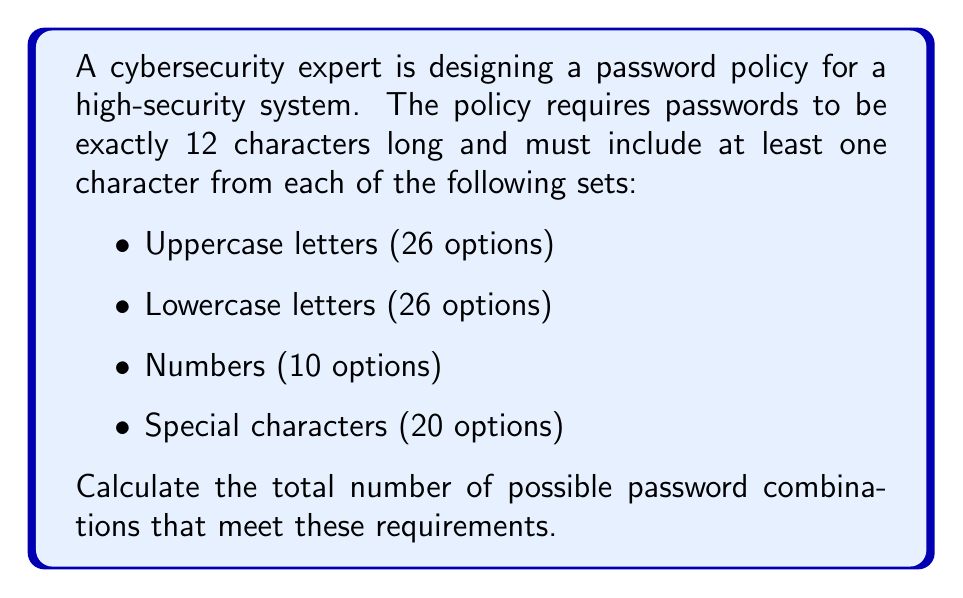Can you solve this math problem? To solve this problem, we'll use the multiplication principle and the inclusion-exclusion principle.

Step 1: Calculate the total number of 12-character strings without restrictions.
$$T = 82^{12}$$ (82 is the sum of all character options: 26 + 26 + 10 + 20)

Step 2: Calculate the number of strings missing at least one character set.
Let A, B, C, and D represent the sets of strings missing uppercase, lowercase, numbers, and special characters, respectively.

$$|A| = 56^{12}$$
$$|B| = 56^{12}$$
$$|C| = 72^{12}$$
$$|D| = 62^{12}$$

Step 3: Apply the inclusion-exclusion principle:

$$|A \cup B \cup C \cup D| = |A| + |B| + |C| + |D|$$
$$- (|A \cap B| + |A \cap C| + |A \cap D| + |B \cap C| + |B \cap D| + |C \cap D|)$$
$$+ (|A \cap B \cap C| + |A \cap B \cap D| + |A \cap C \cap D| + |B \cap C \cap D|)$$
$$- |A \cap B \cap C \cap D|$$

$$= 56^{12} + 56^{12} + 72^{12} + 62^{12}$$
$$- (30^{12} + 46^{12} + 36^{12} + 46^{12} + 36^{12} + 52^{12})$$
$$+ (20^{12} + 10^{12} + 26^{12} + 26^{12})$$
$$- 0^{12}$$

Step 4: Subtract the result from step 3 from the total in step 1 to get the number of valid passwords:

$$\text{Valid passwords} = 82^{12} - |A \cup B \cup C \cup D|$$

Step 5: Calculate the final result:

$$82^{12} - (56^{12} + 56^{12} + 72^{12} + 62^{12} - 30^{12} - 46^{12} - 36^{12} - 46^{12} - 36^{12} - 52^{12} + 20^{12} + 10^{12} + 26^{12} + 26^{12})$$
Answer: The total number of possible password combinations that meet the requirements is:

$$3.0843 \times 10^{23}$$ (rounded to 4 significant figures) 